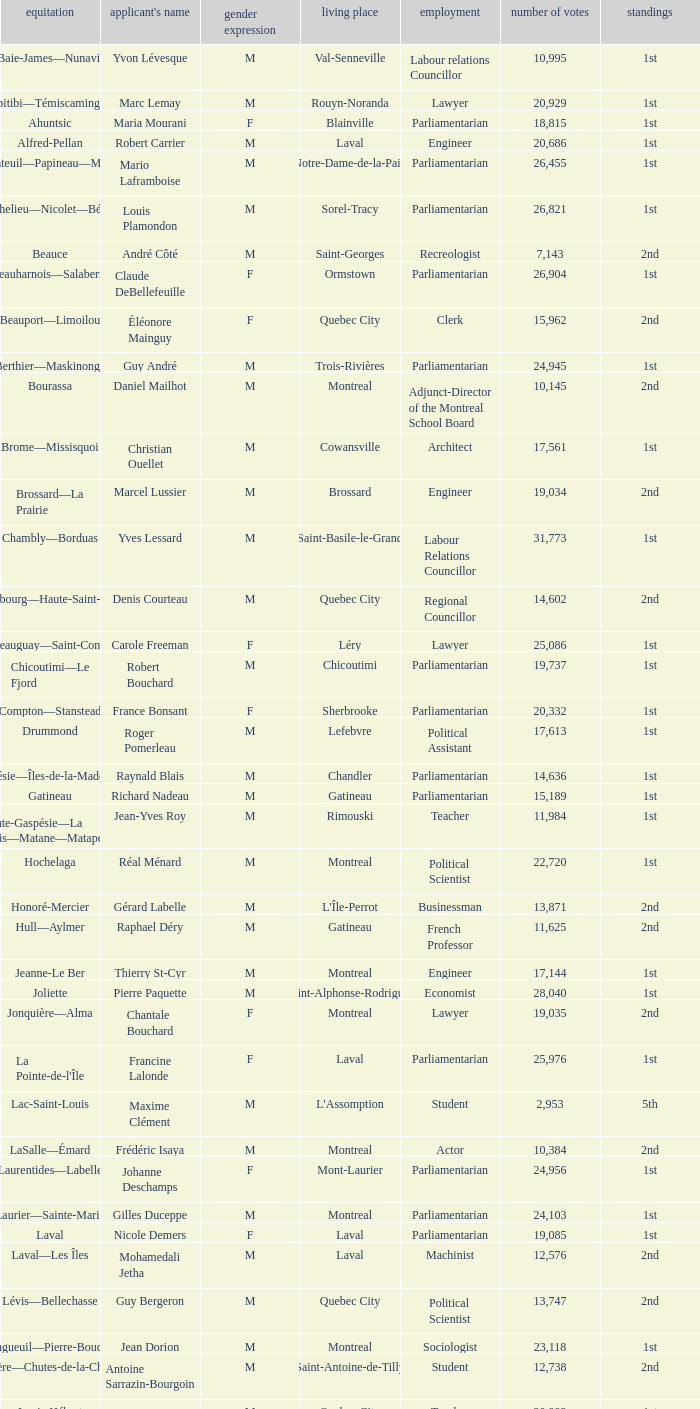What gender is Luc Desnoyers? M. 